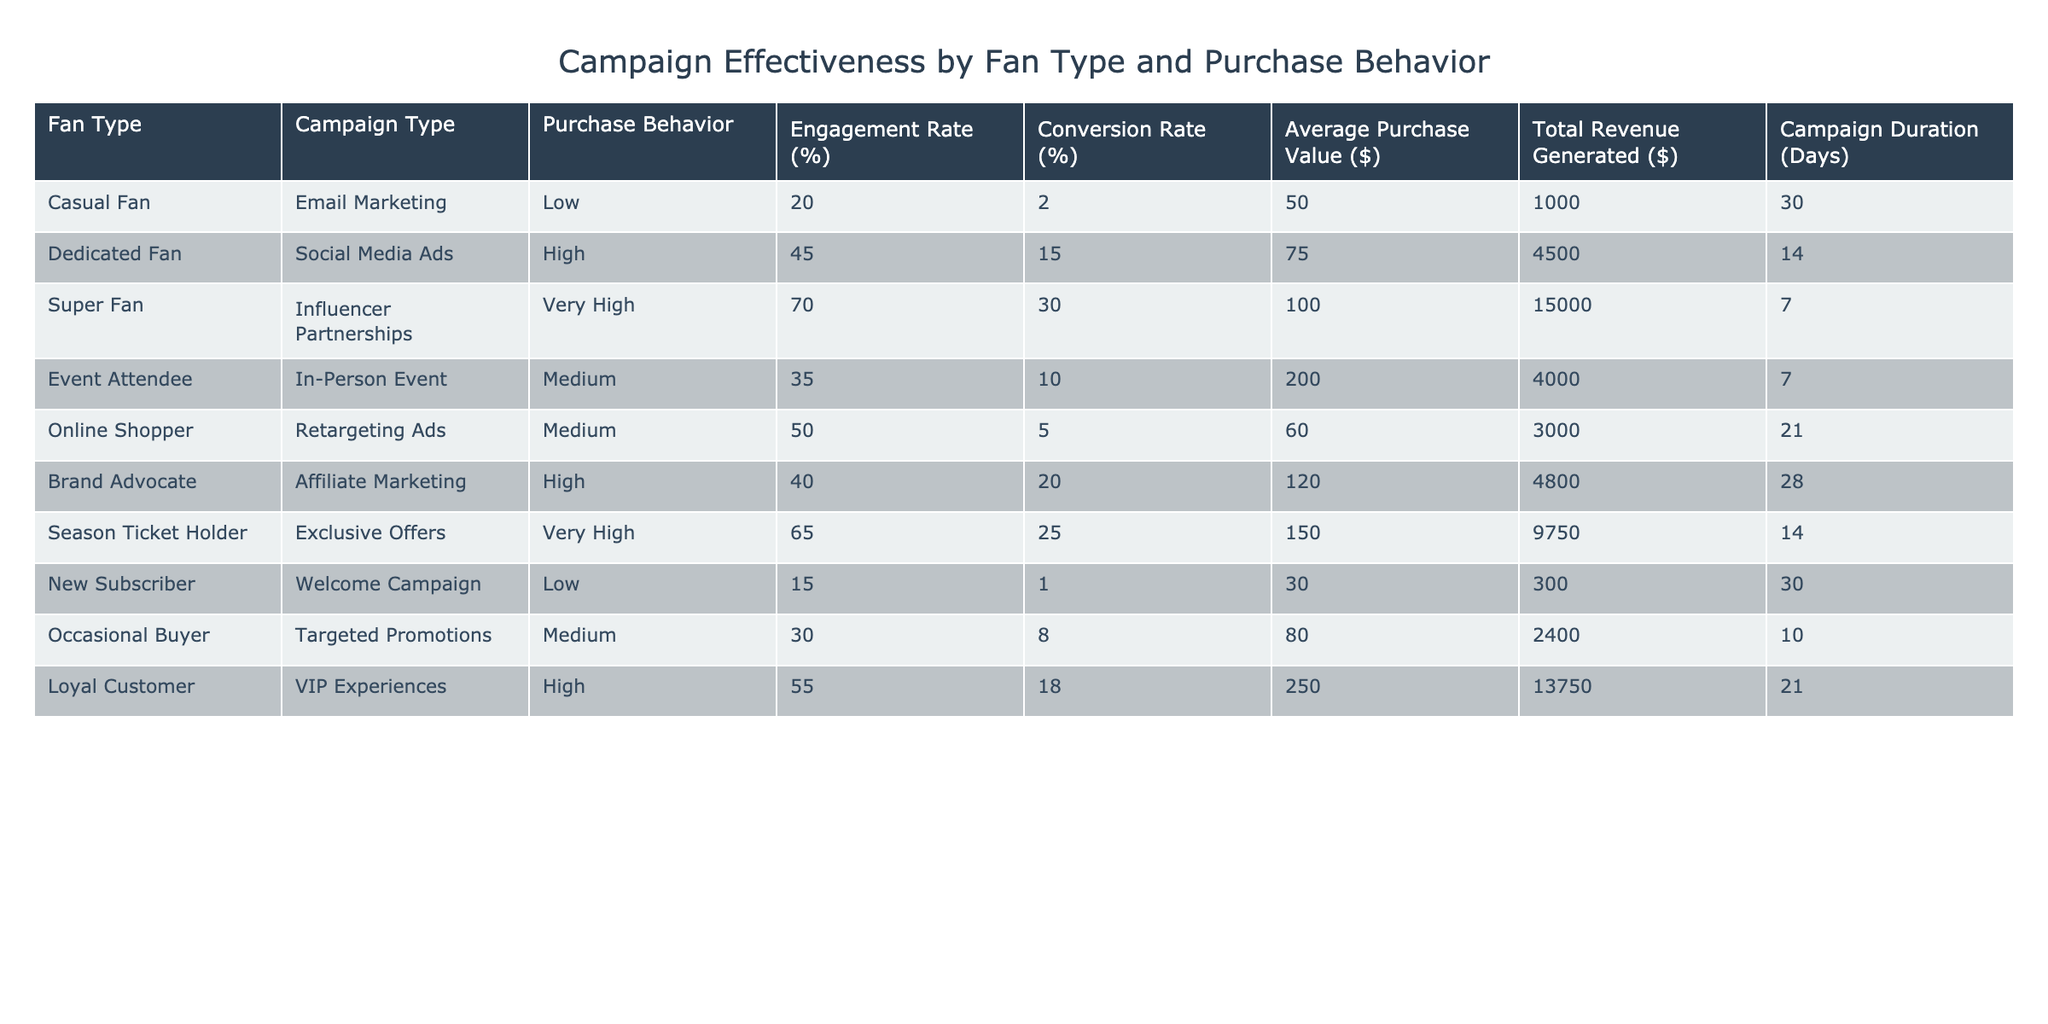What is the engagement rate for Super Fans? According to the table, the engagement rate for Super Fans is listed directly in the "Engagement Rate (%)" column for that fan type, which is 70%.
Answer: 70% Which campaign type has the highest conversion rate? By looking at the "Conversion Rate (%)" column, the Super Fans under "Influencer Partnerships" have the highest conversion rate listed at 30%.
Answer: Influencer Partnerships What is the total revenue generated by Dedicated Fans through Social Media Ads? The total revenue generated by Dedicated Fans can be found in the "Total Revenue Generated ($)" column specifically for the Social Media Ads campaign, which is 4500 dollars.
Answer: 4500 How much higher is the average purchase value for Loyal Customers compared to Casual Fans? To find the difference, we look at the "Average Purchase Value ($)" for both groups: Loyal Customers have an average value of 250 dollars and Casual Fans have 50 dollars. The difference: 250 - 50 = 200 dollars.
Answer: 200 Is the engagement rate for Brand Advocates higher than that of Occasional Buyers? The engagement rate for Brand Advocates is 40%, while for Occasional Buyers it is 30%. Since 40% is greater than 30%, the statement is true.
Answer: Yes What is the average conversion rate for campaigns with a duration of 14 days? We identify the campaigns lasting 14 days: Dedicated Fans with 15%, and Season Ticket Holders with 25%. The average conversion rate is calculated as (15 + 25) / 2 = 20%.
Answer: 20 Which fan type generates the most total revenue? By evaluating the "Total Revenue Generated ($)" across all fan types, the Super Fans generate the most revenue at 15000 dollars through Influencer Partnerships.
Answer: Super Fans How many different campaign types have a low engagement rate? We can look at the "Engagement Rate (%)" column and identify the campaigns with a low engagement rate (less than 25%): Casual Fans (20%) and New Subscribers (15%). Together, this indicates there are 2 distinct types.
Answer: 2 What is the difference in campaign duration between the longest and shortest campaigns? The longest campaign is the Dedicated Fans at 14 days and the shortest is the Super Fans at 7 days. The difference in duration is 14 - 7 = 7 days.
Answer: 7 